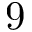<formula> <loc_0><loc_0><loc_500><loc_500>9</formula> 